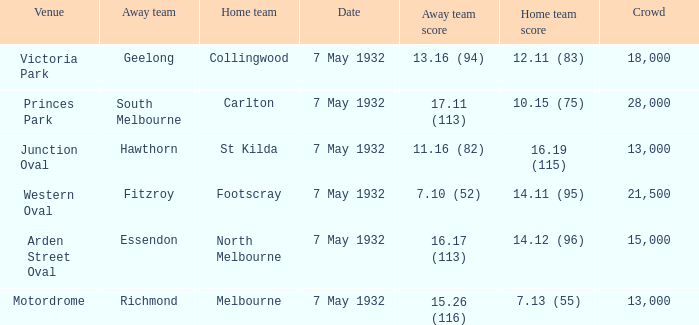What is the home team for victoria park? Collingwood. 